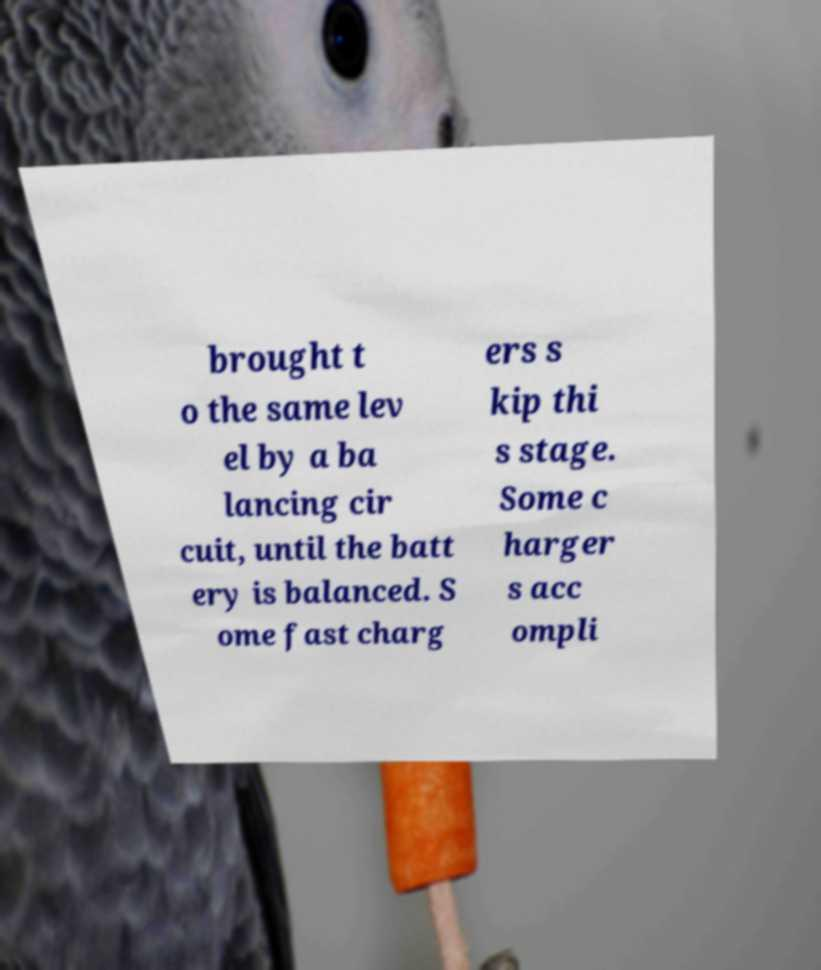Please read and relay the text visible in this image. What does it say? brought t o the same lev el by a ba lancing cir cuit, until the batt ery is balanced. S ome fast charg ers s kip thi s stage. Some c harger s acc ompli 